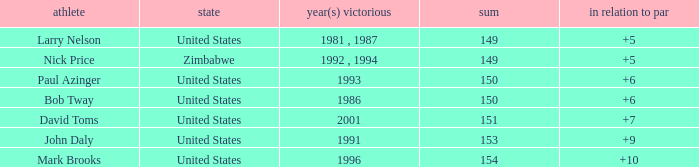What is the total for 1986 with a to par higher than 6? 0.0. 